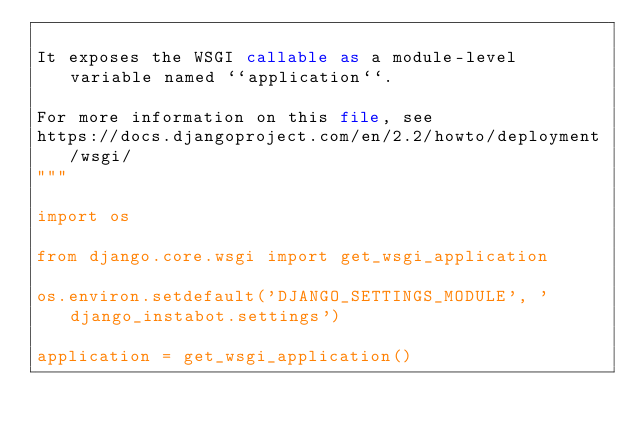Convert code to text. <code><loc_0><loc_0><loc_500><loc_500><_Python_>
It exposes the WSGI callable as a module-level variable named ``application``.

For more information on this file, see
https://docs.djangoproject.com/en/2.2/howto/deployment/wsgi/
"""

import os

from django.core.wsgi import get_wsgi_application

os.environ.setdefault('DJANGO_SETTINGS_MODULE', 'django_instabot.settings')

application = get_wsgi_application()
</code> 